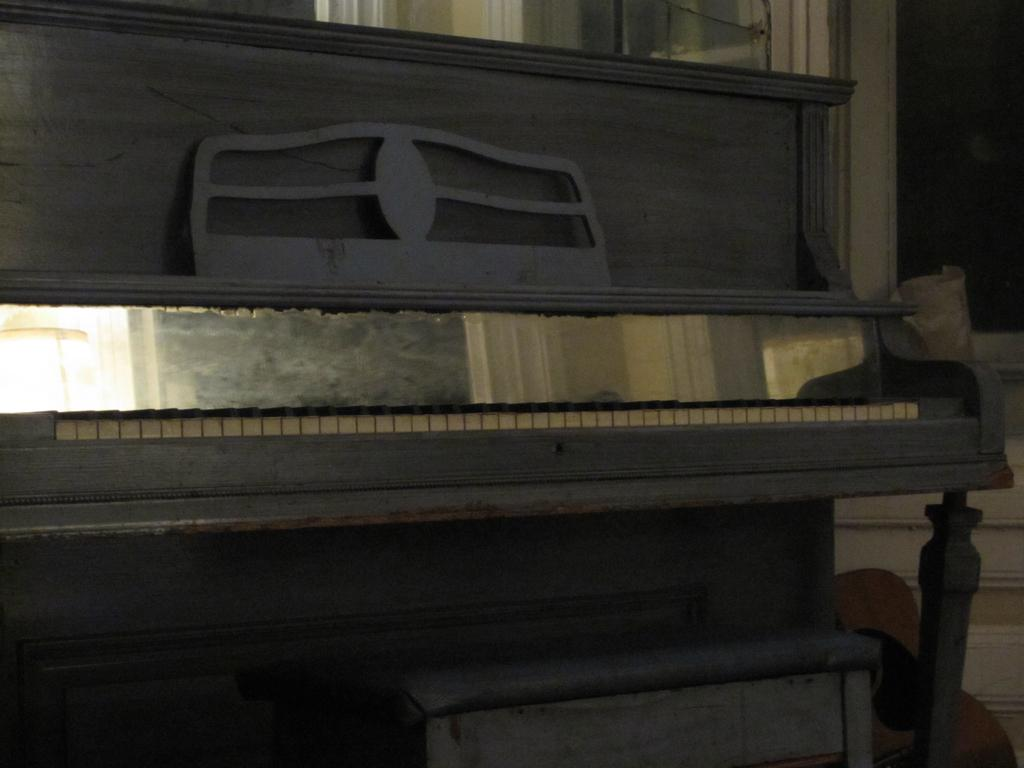What musical instrument is present in the image? There is a piano in the image. Where is the piano located in the room? The piano is on the floor. What type of apparel is the piano wearing in the image? Pianos do not wear apparel, as they are inanimate objects. 